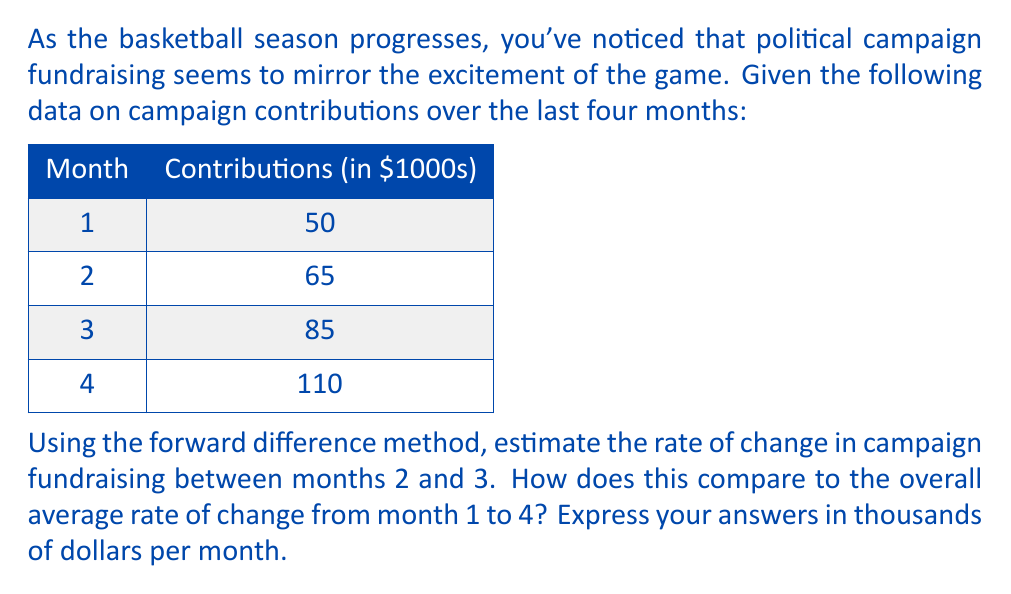Solve this math problem. Let's approach this step-by-step, just like we'd break down a game strategy:

1) The forward difference method estimates the rate of change using the formula:

   $$f'(x) \approx \frac{f(x+h) - f(x)}{h}$$

   where $h$ is the step size (in this case, 1 month).

2) For months 2 and 3:
   $$\text{Rate of change} \approx \frac{f(3) - f(2)}{3-2} = \frac{85 - 65}{1} = 20$$

3) The overall average rate of change from month 1 to 4 is calculated using:

   $$\text{Average rate} = \frac{f(4) - f(1)}{4-1} = \frac{110 - 50}{3} = 20$$

4) Both the forward difference estimate between months 2 and 3 and the overall average rate from month 1 to 4 are $20,000 per month.

This consistency might remind us of a team that maintains a steady improvement throughout the season, much like how sustained political engagement can lead to consistent growth in campaign support.
Answer: Forward difference estimate (months 2-3): $20,000/month
Overall average rate (months 1-4): $20,000/month 